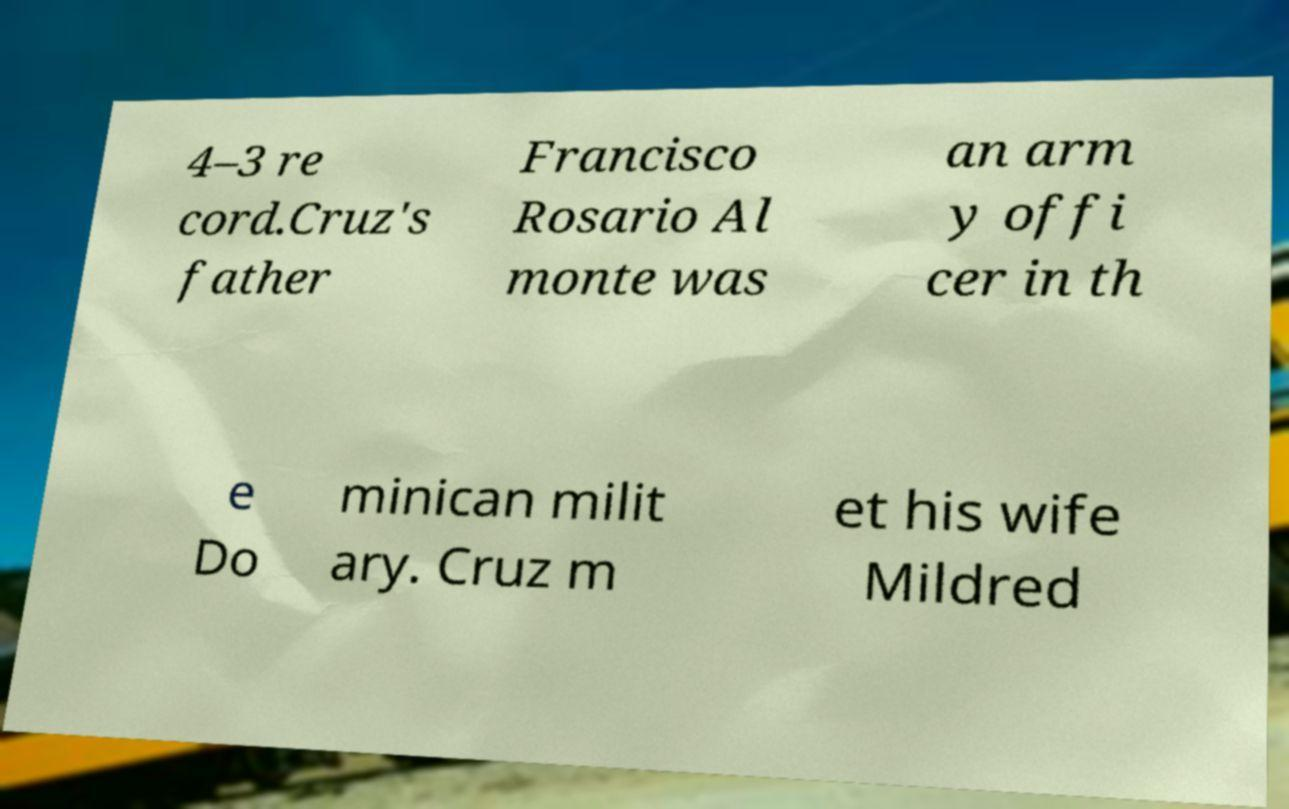Could you assist in decoding the text presented in this image and type it out clearly? 4–3 re cord.Cruz's father Francisco Rosario Al monte was an arm y offi cer in th e Do minican milit ary. Cruz m et his wife Mildred 